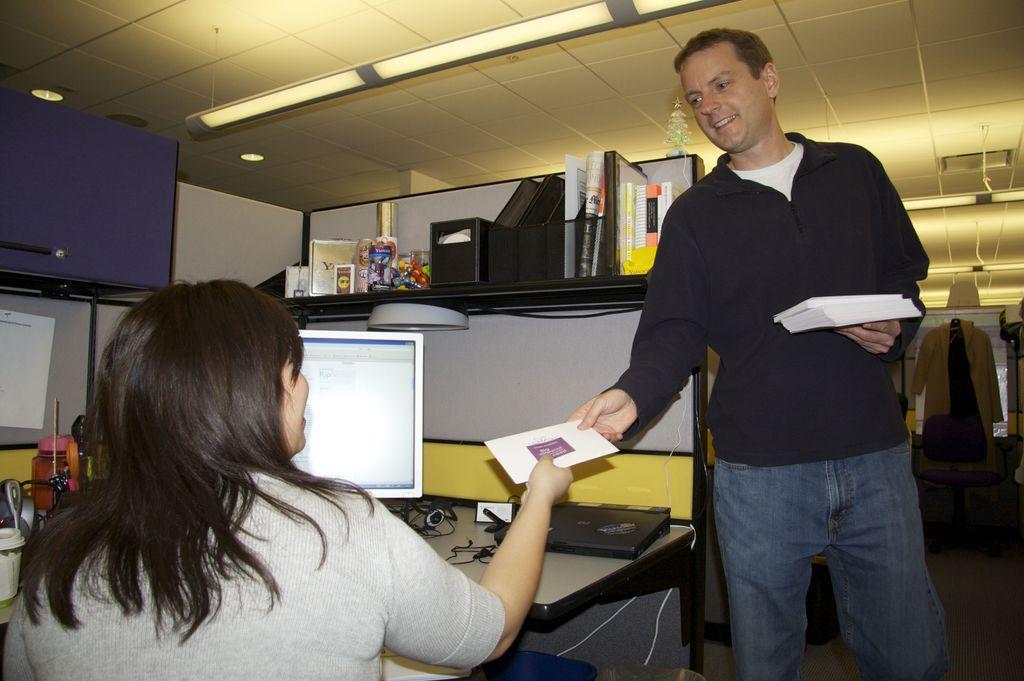Can you describe this image briefly? In the image we can see there is a woman sitting on the chair and there is a man holding cards in his hand. There is a woman holding a card and there is a monitor, files and glass kept on the table. There are tube lights on the top. 